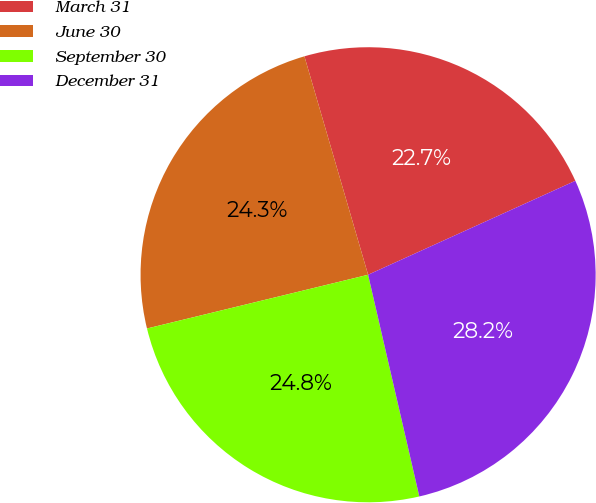<chart> <loc_0><loc_0><loc_500><loc_500><pie_chart><fcel>March 31<fcel>June 30<fcel>September 30<fcel>December 31<nl><fcel>22.74%<fcel>24.28%<fcel>24.82%<fcel>28.16%<nl></chart> 